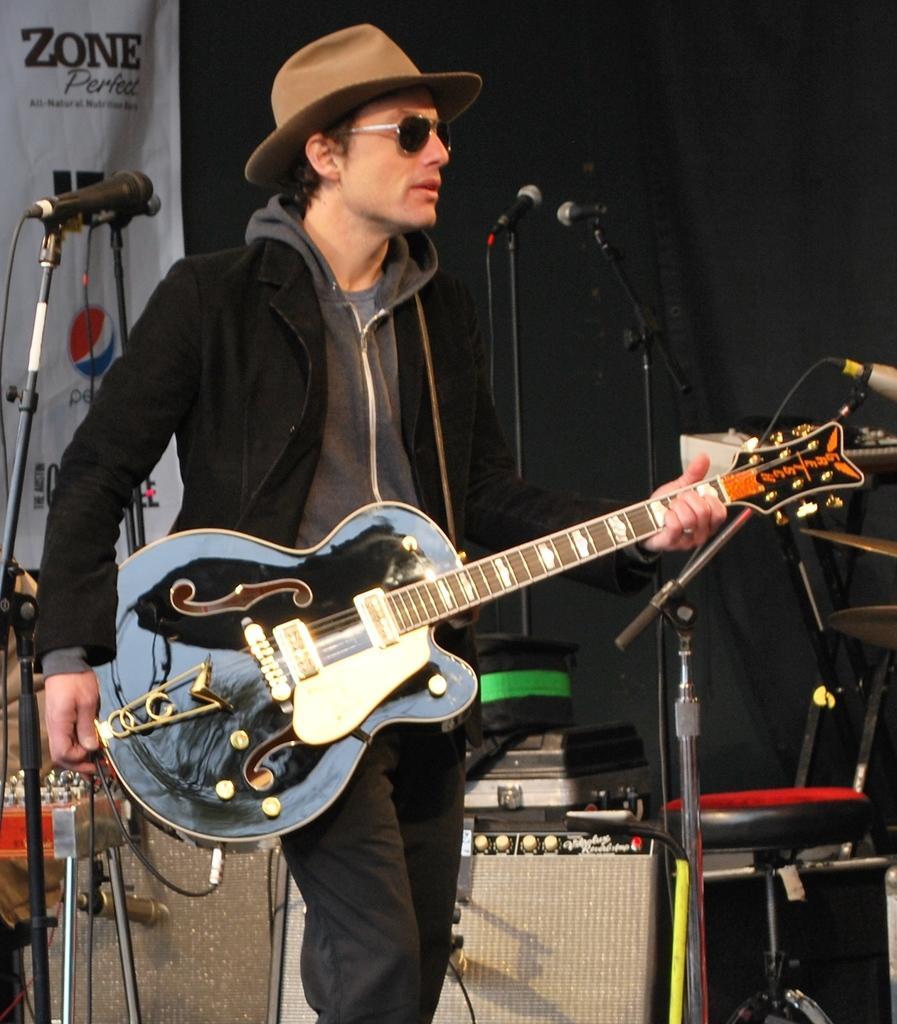How would you summarize this image in a sentence or two? In the image there is a man with goggles and a hat on his head. And holding a guitar in his hand. Behind him there are few stands with mics, speakers, chairs and some other things. In the background there is a banner and also there is a black cloth. 